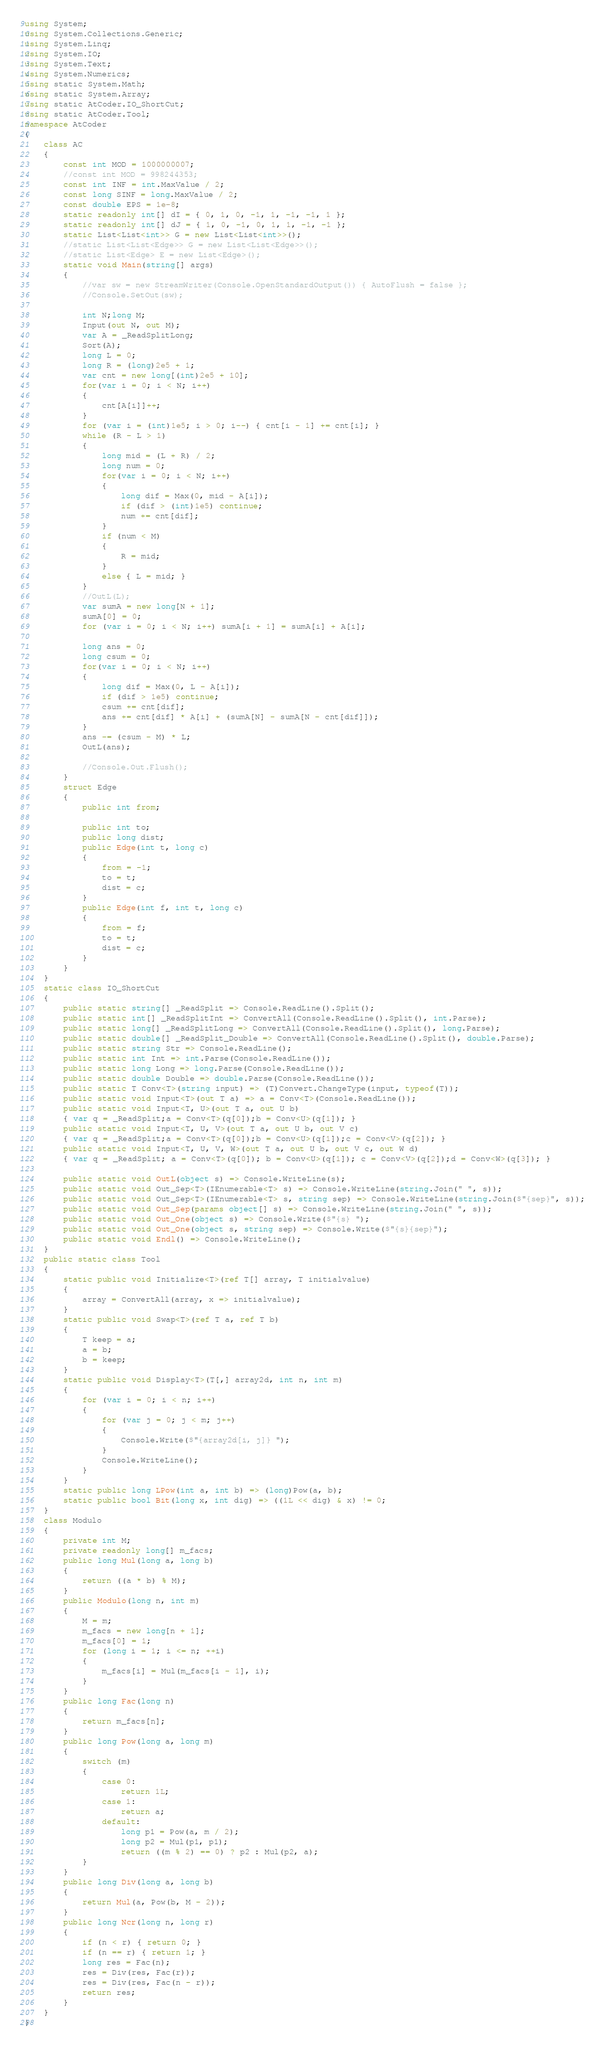<code> <loc_0><loc_0><loc_500><loc_500><_C#_>using System;
using System.Collections.Generic;
using System.Linq;
using System.IO;
using System.Text;
using System.Numerics;
using static System.Math;
using static System.Array;
using static AtCoder.IO_ShortCut;
using static AtCoder.Tool;
namespace AtCoder
{
    class AC
    {
        const int MOD = 1000000007;
        //const int MOD = 998244353;
        const int INF = int.MaxValue / 2;
        const long SINF = long.MaxValue / 2;
        const double EPS = 1e-8;
        static readonly int[] dI = { 0, 1, 0, -1, 1, -1, -1, 1 };
        static readonly int[] dJ = { 1, 0, -1, 0, 1, 1, -1, -1 };
        static List<List<int>> G = new List<List<int>>();
        //static List<List<Edge>> G = new List<List<Edge>>();
        //static List<Edge> E = new List<Edge>();
        static void Main(string[] args)
        {
            //var sw = new StreamWriter(Console.OpenStandardOutput()) { AutoFlush = false };
            //Console.SetOut(sw);

            int N;long M;
            Input(out N, out M);
            var A = _ReadSplitLong;
            Sort(A);
            long L = 0;
            long R = (long)2e5 + 1;
            var cnt = new long[(int)2e5 + 10];
            for(var i = 0; i < N; i++)
            {
                cnt[A[i]]++;
            }
            for (var i = (int)1e5; i > 0; i--) { cnt[i - 1] += cnt[i]; }
            while (R - L > 1)
            {
                long mid = (L + R) / 2;
                long num = 0;
                for(var i = 0; i < N; i++)
                {
                    long dif = Max(0, mid - A[i]);
                    if (dif > (int)1e5) continue;
                    num += cnt[dif];
                }
                if (num < M)
                {
                    R = mid;
                }
                else { L = mid; }
            }
            //OutL(L);
            var sumA = new long[N + 1];
            sumA[0] = 0;
            for (var i = 0; i < N; i++) sumA[i + 1] = sumA[i] + A[i];

            long ans = 0;
            long csum = 0;
            for(var i = 0; i < N; i++)
            {
                long dif = Max(0, L - A[i]);
                if (dif > 1e5) continue;
                csum += cnt[dif];
                ans += cnt[dif] * A[i] + (sumA[N] - sumA[N - cnt[dif]]);
            }
            ans -= (csum - M) * L;
            OutL(ans);

            //Console.Out.Flush();
        }
        struct Edge
        {
            public int from;

            public int to;
            public long dist;
            public Edge(int t, long c)
            {
                from = -1;
                to = t;
                dist = c;
            }
            public Edge(int f, int t, long c)
            {
                from = f;
                to = t;
                dist = c;
            }
        }
    }
    static class IO_ShortCut
    {
        public static string[] _ReadSplit => Console.ReadLine().Split();
        public static int[] _ReadSplitInt => ConvertAll(Console.ReadLine().Split(), int.Parse);
        public static long[] _ReadSplitLong => ConvertAll(Console.ReadLine().Split(), long.Parse);
        public static double[] _ReadSplit_Double => ConvertAll(Console.ReadLine().Split(), double.Parse);
        public static string Str => Console.ReadLine();
        public static int Int => int.Parse(Console.ReadLine());
        public static long Long => long.Parse(Console.ReadLine());
        public static double Double => double.Parse(Console.ReadLine());
        public static T Conv<T>(string input) => (T)Convert.ChangeType(input, typeof(T));
        public static void Input<T>(out T a) => a = Conv<T>(Console.ReadLine());
        public static void Input<T, U>(out T a, out U b)
        { var q = _ReadSplit;a = Conv<T>(q[0]);b = Conv<U>(q[1]); }
        public static void Input<T, U, V>(out T a, out U b, out V c)
        { var q = _ReadSplit;a = Conv<T>(q[0]);b = Conv<U>(q[1]);c = Conv<V>(q[2]); }
        public static void Input<T, U, V, W>(out T a, out U b, out V c, out W d)
        { var q = _ReadSplit; a = Conv<T>(q[0]); b = Conv<U>(q[1]); c = Conv<V>(q[2]);d = Conv<W>(q[3]); }

        public static void OutL(object s) => Console.WriteLine(s);
        public static void Out_Sep<T>(IEnumerable<T> s) => Console.WriteLine(string.Join(" ", s));
        public static void Out_Sep<T>(IEnumerable<T> s, string sep) => Console.WriteLine(string.Join($"{sep}", s));
        public static void Out_Sep(params object[] s) => Console.WriteLine(string.Join(" ", s));
        public static void Out_One(object s) => Console.Write($"{s} ");
        public static void Out_One(object s, string sep) => Console.Write($"{s}{sep}");
        public static void Endl() => Console.WriteLine();
    }
    public static class Tool
    {
        static public void Initialize<T>(ref T[] array, T initialvalue)
        {
            array = ConvertAll(array, x => initialvalue);
        }
        static public void Swap<T>(ref T a, ref T b)
        {
            T keep = a;
            a = b;
            b = keep;
        }
        static public void Display<T>(T[,] array2d, int n, int m)
        {
            for (var i = 0; i < n; i++)
            {
                for (var j = 0; j < m; j++)
                {
                    Console.Write($"{array2d[i, j]} ");
                }
                Console.WriteLine();
            }
        }
        static public long LPow(int a, int b) => (long)Pow(a, b);
        static public bool Bit(long x, int dig) => ((1L << dig) & x) != 0;
    }
    class Modulo
    {
        private int M;
        private readonly long[] m_facs;
        public long Mul(long a, long b)
        {
            return ((a * b) % M);
        }
        public Modulo(long n, int m)
        {
            M = m;
            m_facs = new long[n + 1];
            m_facs[0] = 1;
            for (long i = 1; i <= n; ++i)
            {
                m_facs[i] = Mul(m_facs[i - 1], i);
            }
        }
        public long Fac(long n)
        {
            return m_facs[n];
        }
        public long Pow(long a, long m)
        {
            switch (m)
            {
                case 0:
                    return 1L;
                case 1:
                    return a;
                default:
                    long p1 = Pow(a, m / 2);
                    long p2 = Mul(p1, p1);
                    return ((m % 2) == 0) ? p2 : Mul(p2, a);
            }
        }
        public long Div(long a, long b)
        {
            return Mul(a, Pow(b, M - 2));
        }
        public long Ncr(long n, long r)
        {
            if (n < r) { return 0; }
            if (n == r) { return 1; }
            long res = Fac(n);
            res = Div(res, Fac(r));
            res = Div(res, Fac(n - r));
            return res;
        }
    }
}
</code> 